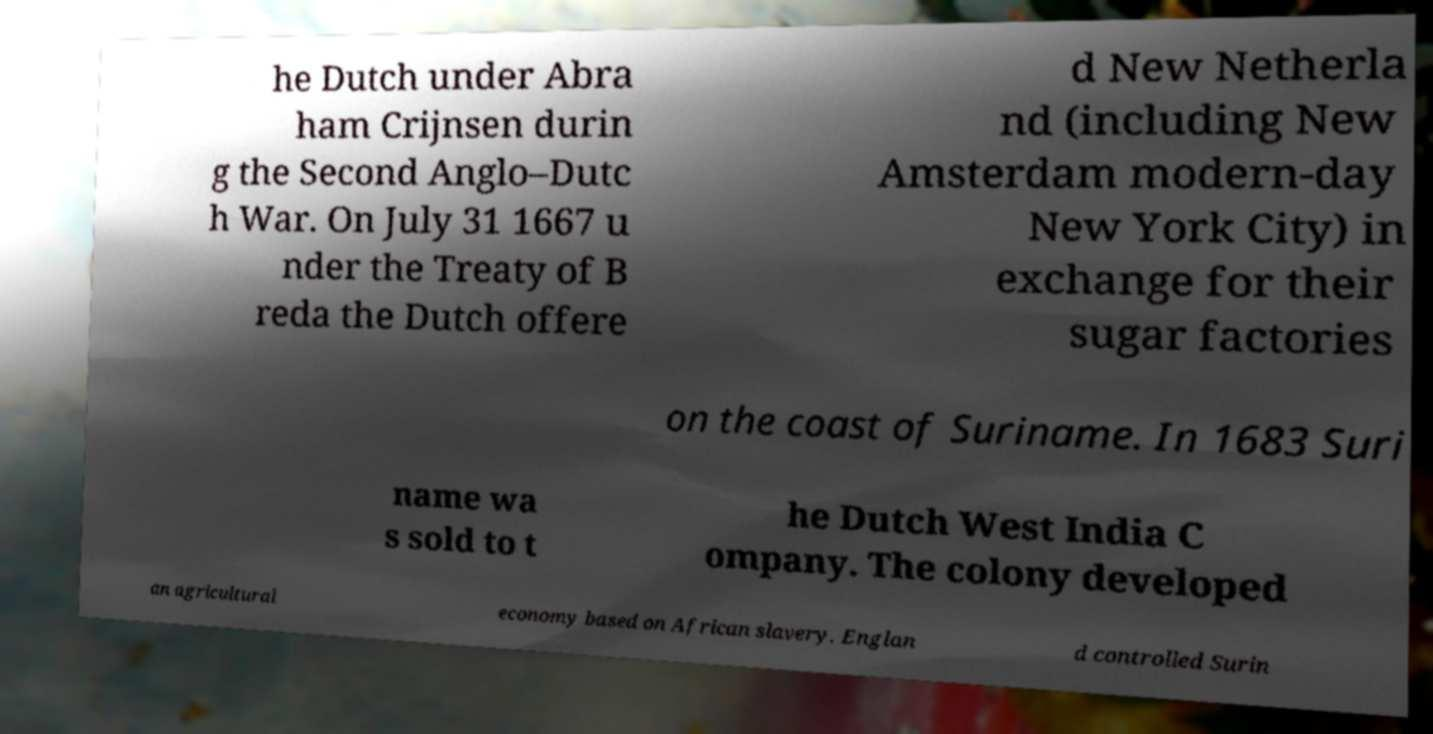There's text embedded in this image that I need extracted. Can you transcribe it verbatim? he Dutch under Abra ham Crijnsen durin g the Second Anglo–Dutc h War. On July 31 1667 u nder the Treaty of B reda the Dutch offere d New Netherla nd (including New Amsterdam modern-day New York City) in exchange for their sugar factories on the coast of Suriname. In 1683 Suri name wa s sold to t he Dutch West India C ompany. The colony developed an agricultural economy based on African slavery. Englan d controlled Surin 